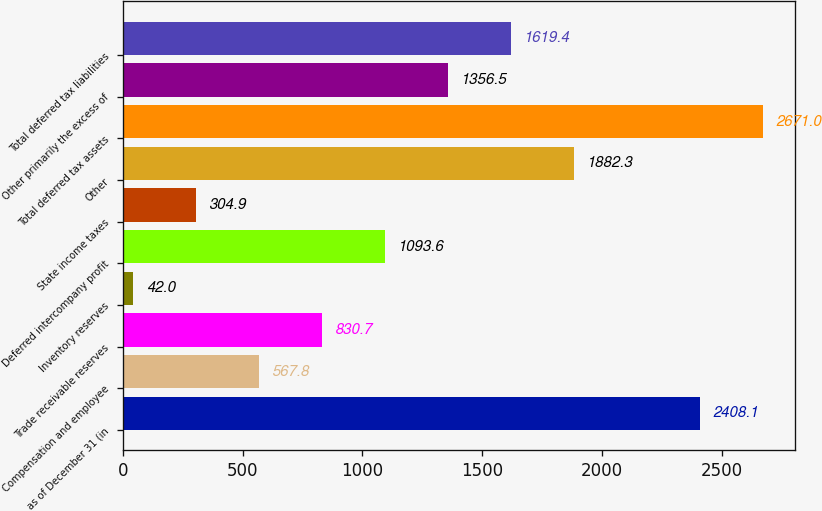Convert chart. <chart><loc_0><loc_0><loc_500><loc_500><bar_chart><fcel>as of December 31 (in<fcel>Compensation and employee<fcel>Trade receivable reserves<fcel>Inventory reserves<fcel>Deferred intercompany profit<fcel>State income taxes<fcel>Other<fcel>Total deferred tax assets<fcel>Other primarily the excess of<fcel>Total deferred tax liabilities<nl><fcel>2408.1<fcel>567.8<fcel>830.7<fcel>42<fcel>1093.6<fcel>304.9<fcel>1882.3<fcel>2671<fcel>1356.5<fcel>1619.4<nl></chart> 